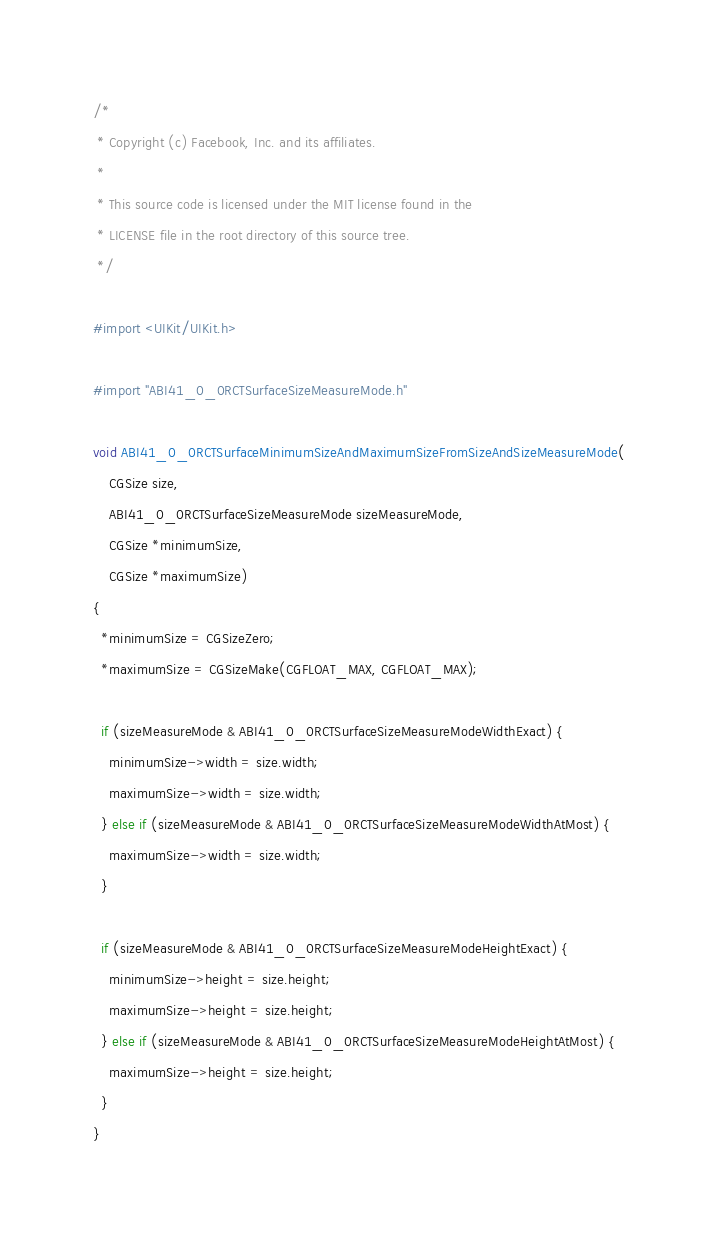<code> <loc_0><loc_0><loc_500><loc_500><_ObjectiveC_>/*
 * Copyright (c) Facebook, Inc. and its affiliates.
 *
 * This source code is licensed under the MIT license found in the
 * LICENSE file in the root directory of this source tree.
 */

#import <UIKit/UIKit.h>

#import "ABI41_0_0RCTSurfaceSizeMeasureMode.h"

void ABI41_0_0RCTSurfaceMinimumSizeAndMaximumSizeFromSizeAndSizeMeasureMode(
    CGSize size,
    ABI41_0_0RCTSurfaceSizeMeasureMode sizeMeasureMode,
    CGSize *minimumSize,
    CGSize *maximumSize)
{
  *minimumSize = CGSizeZero;
  *maximumSize = CGSizeMake(CGFLOAT_MAX, CGFLOAT_MAX);

  if (sizeMeasureMode & ABI41_0_0RCTSurfaceSizeMeasureModeWidthExact) {
    minimumSize->width = size.width;
    maximumSize->width = size.width;
  } else if (sizeMeasureMode & ABI41_0_0RCTSurfaceSizeMeasureModeWidthAtMost) {
    maximumSize->width = size.width;
  }

  if (sizeMeasureMode & ABI41_0_0RCTSurfaceSizeMeasureModeHeightExact) {
    minimumSize->height = size.height;
    maximumSize->height = size.height;
  } else if (sizeMeasureMode & ABI41_0_0RCTSurfaceSizeMeasureModeHeightAtMost) {
    maximumSize->height = size.height;
  }
}
</code> 